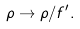Convert formula to latex. <formula><loc_0><loc_0><loc_500><loc_500>\rho \rightarrow \rho / f ^ { \prime } .</formula> 